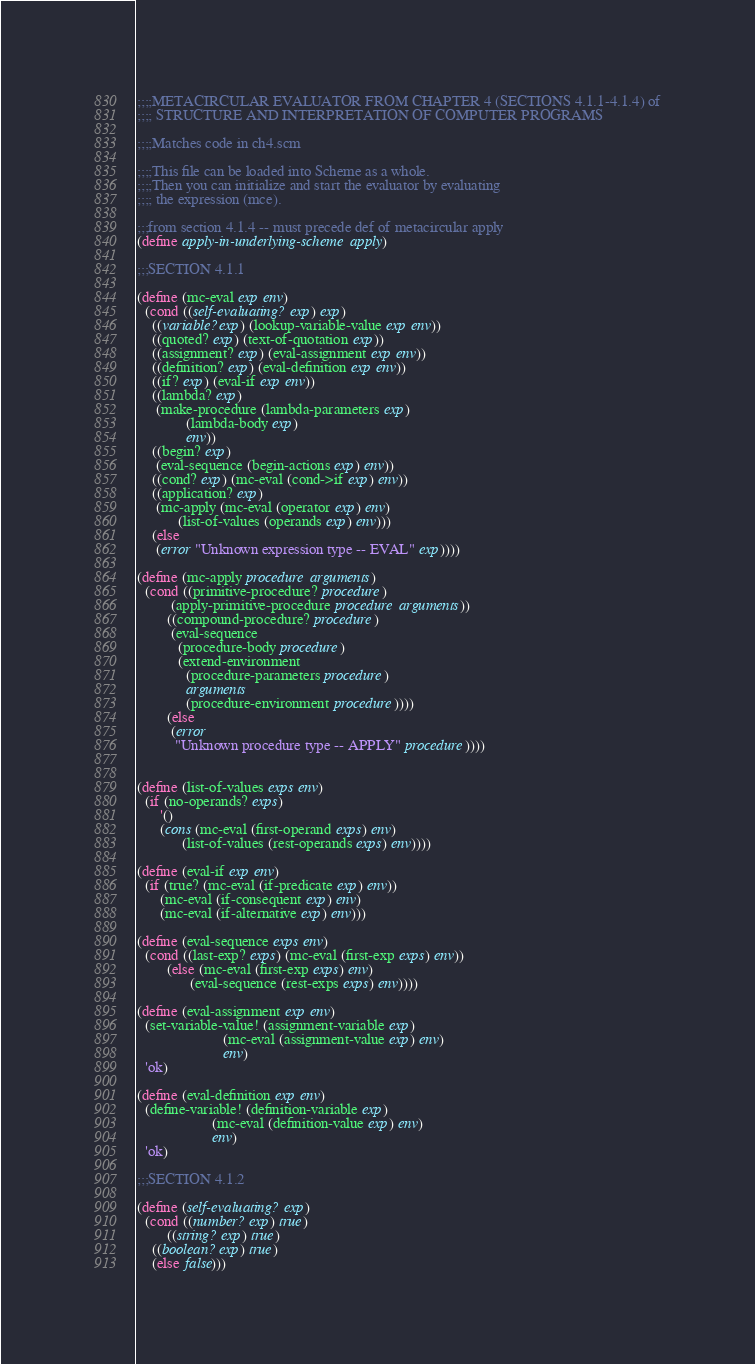<code> <loc_0><loc_0><loc_500><loc_500><_Scheme_>;;;;METACIRCULAR EVALUATOR FROM CHAPTER 4 (SECTIONS 4.1.1-4.1.4) of
;;;; STRUCTURE AND INTERPRETATION OF COMPUTER PROGRAMS

;;;;Matches code in ch4.scm

;;;;This file can be loaded into Scheme as a whole.
;;;;Then you can initialize and start the evaluator by evaluating
;;;; the expression (mce).

;;;from section 4.1.4 -- must precede def of metacircular apply
(define apply-in-underlying-scheme apply)

;;;SECTION 4.1.1

(define (mc-eval exp env)
  (cond ((self-evaluating? exp) exp)
	((variable? exp) (lookup-variable-value exp env))
	((quoted? exp) (text-of-quotation exp))
	((assignment? exp) (eval-assignment exp env))
	((definition? exp) (eval-definition exp env))
	((if? exp) (eval-if exp env))
	((lambda? exp)
	 (make-procedure (lambda-parameters exp)
			 (lambda-body exp)
			 env))
	((begin? exp) 
	 (eval-sequence (begin-actions exp) env))
	((cond? exp) (mc-eval (cond->if exp) env))
	((application? exp)
	 (mc-apply (mc-eval (operator exp) env)
		   (list-of-values (operands exp) env)))
	(else
	 (error "Unknown expression type -- EVAL" exp))))

(define (mc-apply procedure arguments)
  (cond ((primitive-procedure? procedure)
         (apply-primitive-procedure procedure arguments))
        ((compound-procedure? procedure)
         (eval-sequence
           (procedure-body procedure)
           (extend-environment
             (procedure-parameters procedure)
             arguments
             (procedure-environment procedure))))
        (else
         (error
          "Unknown procedure type -- APPLY" procedure))))


(define (list-of-values exps env)
  (if (no-operands? exps)
      '()
      (cons (mc-eval (first-operand exps) env)
            (list-of-values (rest-operands exps) env))))

(define (eval-if exp env)
  (if (true? (mc-eval (if-predicate exp) env))
      (mc-eval (if-consequent exp) env)
      (mc-eval (if-alternative exp) env)))

(define (eval-sequence exps env)
  (cond ((last-exp? exps) (mc-eval (first-exp exps) env))
        (else (mc-eval (first-exp exps) env)
              (eval-sequence (rest-exps exps) env))))

(define (eval-assignment exp env)
  (set-variable-value! (assignment-variable exp)
                       (mc-eval (assignment-value exp) env)
                       env)
  'ok)

(define (eval-definition exp env)
  (define-variable! (definition-variable exp)
                    (mc-eval (definition-value exp) env)
                    env)
  'ok)

;;;SECTION 4.1.2

(define (self-evaluating? exp)
  (cond ((number? exp) true)
        ((string? exp) true)
	((boolean? exp) true)
	(else false)))
</code> 